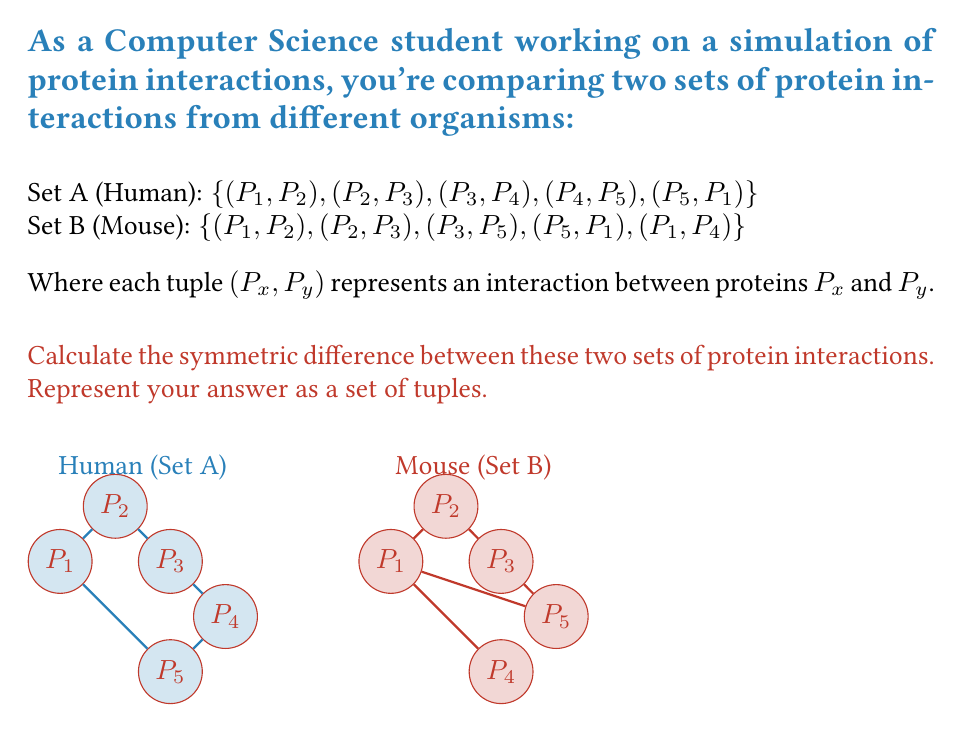Solve this math problem. To solve this problem, we need to find the symmetric difference between sets A and B. The symmetric difference of two sets is defined as the set of elements that are in either of the sets, but not in their intersection. Mathematically, it can be expressed as:

$$ A \triangle B = (A \setminus B) \cup (B \setminus A) $$

Let's break this down step-by-step:

1) First, let's identify the elements in each set:
   Set A = {(P1, P2), (P2, P3), (P3, P4), (P4, P5), (P5, P1)}
   Set B = {(P1, P2), (P2, P3), (P3, P5), (P5, P1), (P1, P4)}

2) Now, let's find $A \setminus B$ (elements in A but not in B):
   $A \setminus B = \{(P3, P4), (P4, P5)\}$

3) Next, let's find $B \setminus A$ (elements in B but not in A):
   $B \setminus A = \{(P3, P5), (P1, P4)\}$

4) The symmetric difference is the union of these two sets:
   $A \triangle B = (A \setminus B) \cup (B \setminus A)$
                 $= \{(P3, P4), (P4, P5)\} \cup \{(P3, P5), (P1, P4)\}$
                 $= \{(P3, P4), (P4, P5), (P3, P5), (P1, P4)\}$

This set represents the protein interactions that are present in one organism but not in the other, which could be particularly interesting for your biological process simulation.
Answer: $\{(P3, P4), (P4, P5), (P3, P5), (P1, P4)\}$ 